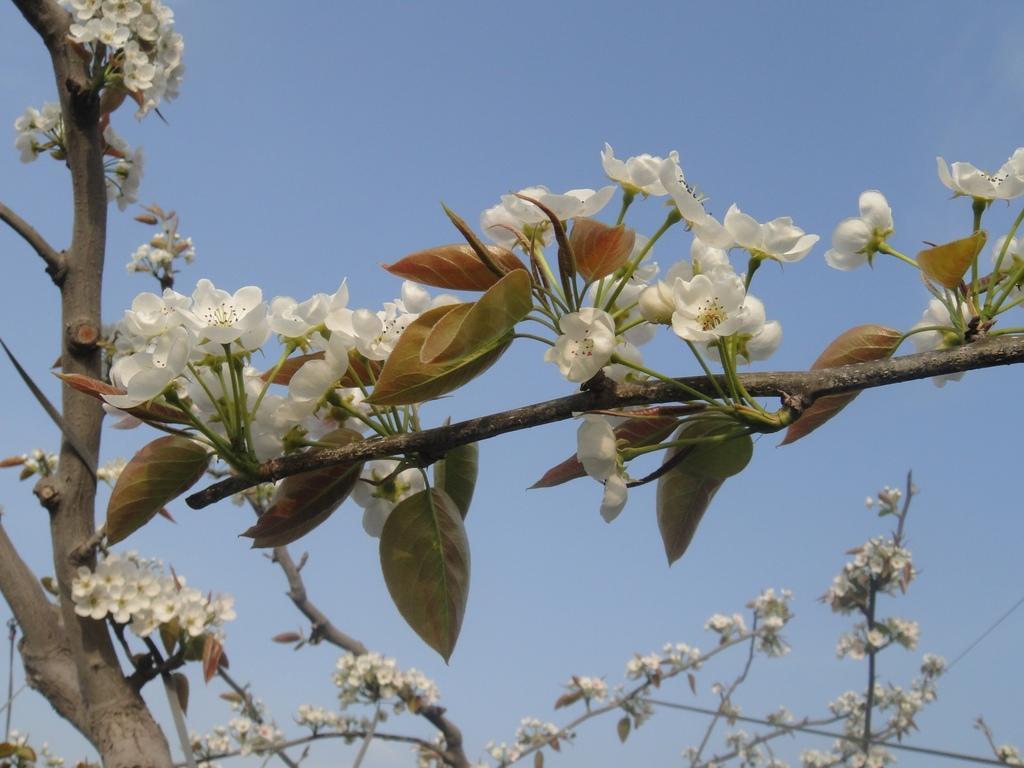How would you summarize this image in a sentence or two? In this image in the front of there are flowers. 